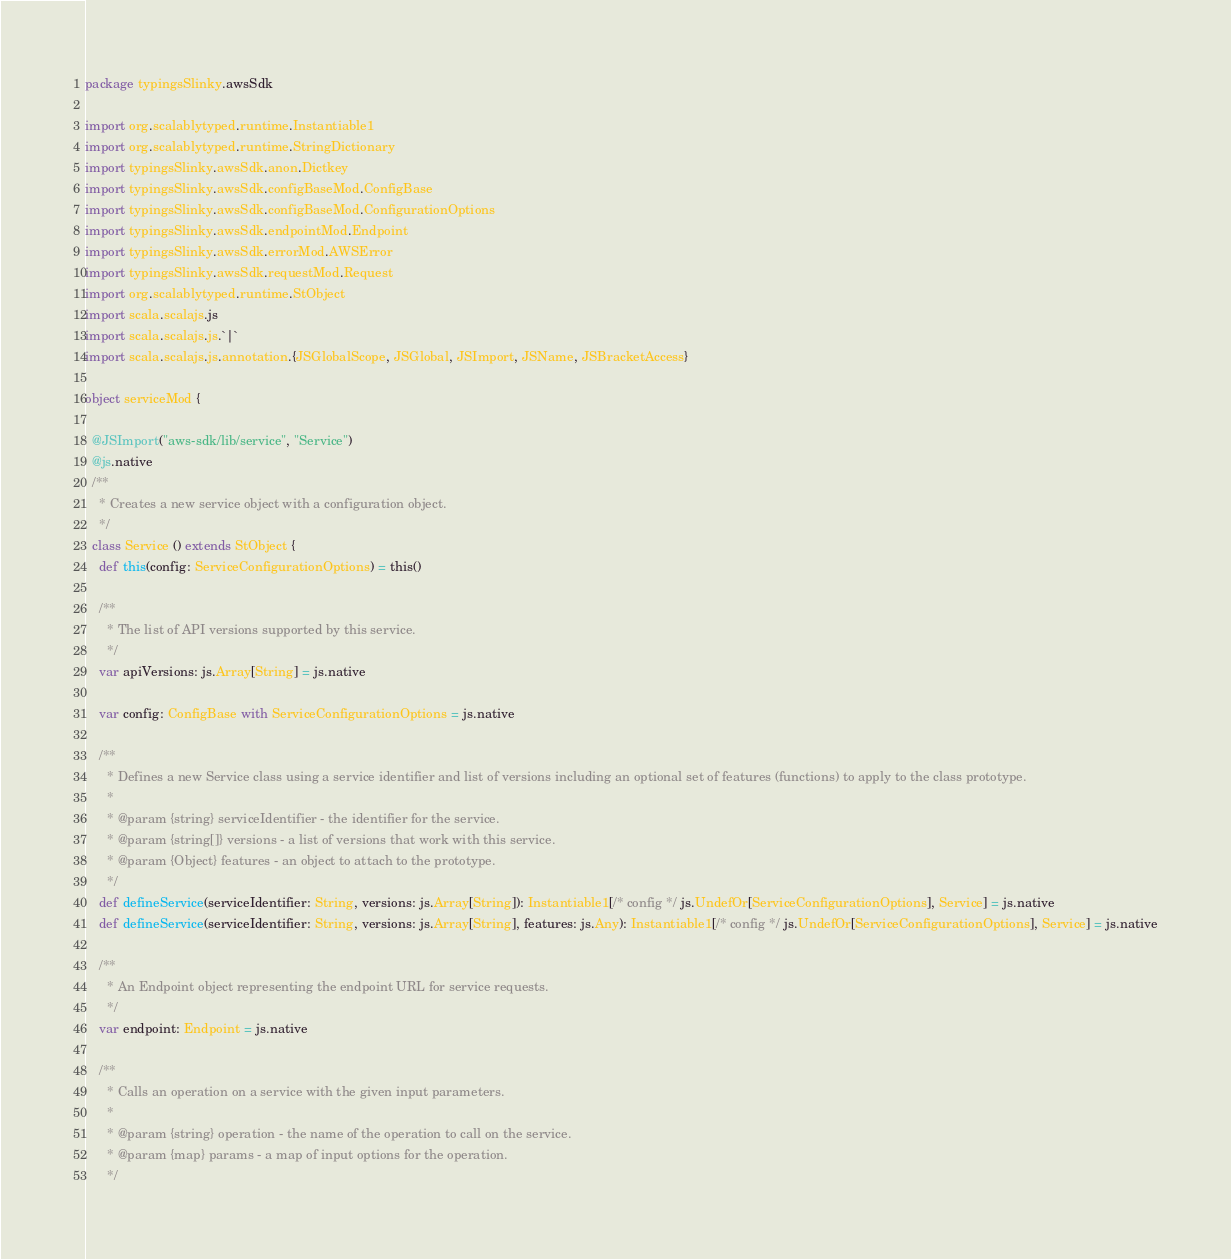<code> <loc_0><loc_0><loc_500><loc_500><_Scala_>package typingsSlinky.awsSdk

import org.scalablytyped.runtime.Instantiable1
import org.scalablytyped.runtime.StringDictionary
import typingsSlinky.awsSdk.anon.Dictkey
import typingsSlinky.awsSdk.configBaseMod.ConfigBase
import typingsSlinky.awsSdk.configBaseMod.ConfigurationOptions
import typingsSlinky.awsSdk.endpointMod.Endpoint
import typingsSlinky.awsSdk.errorMod.AWSError
import typingsSlinky.awsSdk.requestMod.Request
import org.scalablytyped.runtime.StObject
import scala.scalajs.js
import scala.scalajs.js.`|`
import scala.scalajs.js.annotation.{JSGlobalScope, JSGlobal, JSImport, JSName, JSBracketAccess}

object serviceMod {
  
  @JSImport("aws-sdk/lib/service", "Service")
  @js.native
  /**
    * Creates a new service object with a configuration object.
    */
  class Service () extends StObject {
    def this(config: ServiceConfigurationOptions) = this()
    
    /**
      * The list of API versions supported by this service.
      */
    var apiVersions: js.Array[String] = js.native
    
    var config: ConfigBase with ServiceConfigurationOptions = js.native
    
    /**
      * Defines a new Service class using a service identifier and list of versions including an optional set of features (functions) to apply to the class prototype.
      * 
      * @param {string} serviceIdentifier - the identifier for the service.
      * @param {string[]} versions - a list of versions that work with this service.
      * @param {Object} features - an object to attach to the prototype.
      */
    def defineService(serviceIdentifier: String, versions: js.Array[String]): Instantiable1[/* config */ js.UndefOr[ServiceConfigurationOptions], Service] = js.native
    def defineService(serviceIdentifier: String, versions: js.Array[String], features: js.Any): Instantiable1[/* config */ js.UndefOr[ServiceConfigurationOptions], Service] = js.native
    
    /**
      * An Endpoint object representing the endpoint URL for service requests.
      */
    var endpoint: Endpoint = js.native
    
    /**
      * Calls an operation on a service with the given input parameters.
      * 
      * @param {string} operation - the name of the operation to call on the service.
      * @param {map} params - a map of input options for the operation. 
      */</code> 